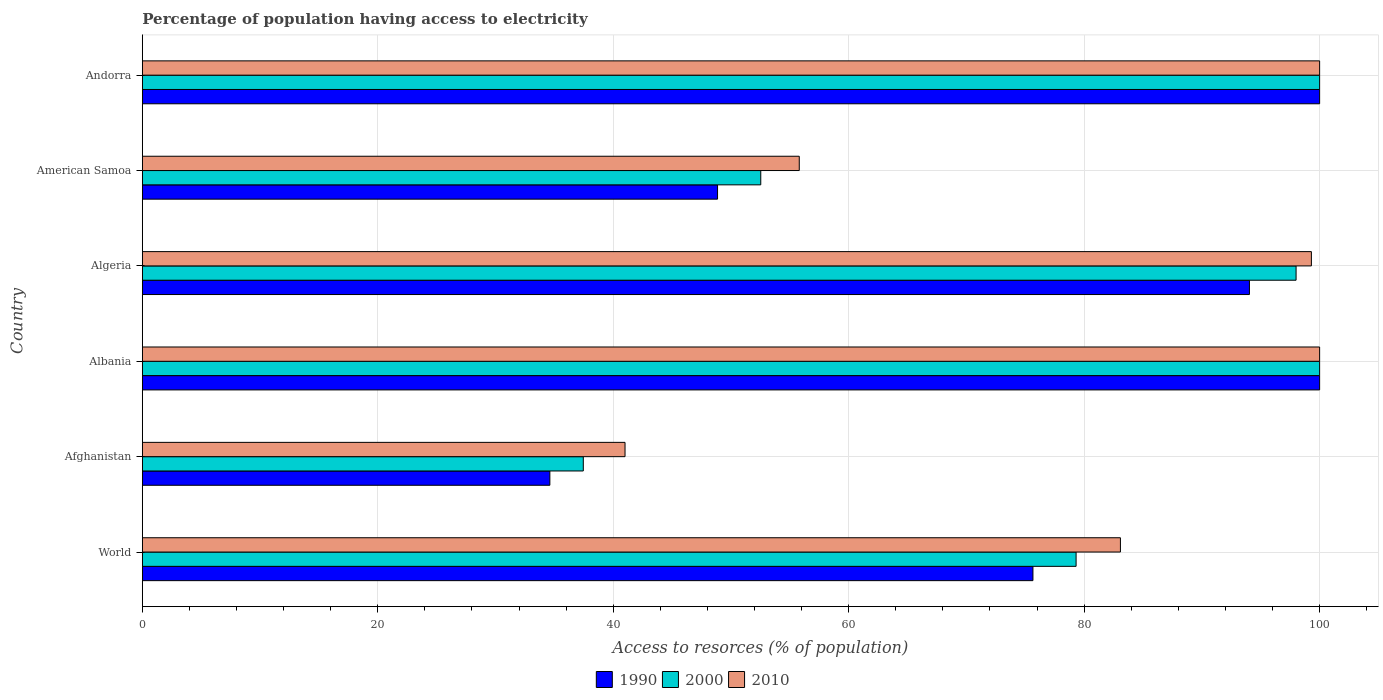Are the number of bars per tick equal to the number of legend labels?
Your answer should be compact. Yes. Are the number of bars on each tick of the Y-axis equal?
Your response must be concise. Yes. What is the percentage of population having access to electricity in 2000 in Albania?
Your answer should be compact. 100. Across all countries, what is the minimum percentage of population having access to electricity in 2010?
Your answer should be very brief. 41. In which country was the percentage of population having access to electricity in 1990 maximum?
Your answer should be very brief. Albania. In which country was the percentage of population having access to electricity in 2010 minimum?
Provide a succinct answer. Afghanistan. What is the total percentage of population having access to electricity in 2000 in the graph?
Your response must be concise. 467.3. What is the difference between the percentage of population having access to electricity in 2010 in Andorra and that in World?
Keep it short and to the point. 16.92. What is the difference between the percentage of population having access to electricity in 2010 in Albania and the percentage of population having access to electricity in 1990 in World?
Your answer should be very brief. 24.35. What is the average percentage of population having access to electricity in 2000 per country?
Your response must be concise. 77.88. What is the difference between the percentage of population having access to electricity in 2000 and percentage of population having access to electricity in 2010 in Algeria?
Ensure brevity in your answer.  -1.3. What is the ratio of the percentage of population having access to electricity in 1990 in Afghanistan to that in World?
Your answer should be compact. 0.46. Is the percentage of population having access to electricity in 2000 in Albania less than that in American Samoa?
Provide a short and direct response. No. What is the difference between the highest and the second highest percentage of population having access to electricity in 1990?
Offer a very short reply. 0. What is the difference between the highest and the lowest percentage of population having access to electricity in 2010?
Give a very brief answer. 59. In how many countries, is the percentage of population having access to electricity in 1990 greater than the average percentage of population having access to electricity in 1990 taken over all countries?
Keep it short and to the point. 4. What does the 1st bar from the top in Andorra represents?
Give a very brief answer. 2010. What does the 1st bar from the bottom in American Samoa represents?
Your response must be concise. 1990. Are all the bars in the graph horizontal?
Ensure brevity in your answer.  Yes. What is the difference between two consecutive major ticks on the X-axis?
Your answer should be compact. 20. Does the graph contain any zero values?
Keep it short and to the point. No. Where does the legend appear in the graph?
Offer a very short reply. Bottom center. What is the title of the graph?
Give a very brief answer. Percentage of population having access to electricity. What is the label or title of the X-axis?
Provide a short and direct response. Access to resorces (% of population). What is the Access to resorces (% of population) of 1990 in World?
Give a very brief answer. 75.65. What is the Access to resorces (% of population) in 2000 in World?
Provide a succinct answer. 79.31. What is the Access to resorces (% of population) of 2010 in World?
Keep it short and to the point. 83.08. What is the Access to resorces (% of population) of 1990 in Afghanistan?
Your answer should be compact. 34.62. What is the Access to resorces (% of population) of 2000 in Afghanistan?
Your answer should be compact. 37.46. What is the Access to resorces (% of population) of 1990 in Albania?
Ensure brevity in your answer.  100. What is the Access to resorces (% of population) of 2000 in Albania?
Your answer should be very brief. 100. What is the Access to resorces (% of population) in 1990 in Algeria?
Offer a very short reply. 94.04. What is the Access to resorces (% of population) in 2010 in Algeria?
Your answer should be very brief. 99.3. What is the Access to resorces (% of population) in 1990 in American Samoa?
Provide a short and direct response. 48.86. What is the Access to resorces (% of population) in 2000 in American Samoa?
Give a very brief answer. 52.53. What is the Access to resorces (% of population) of 2010 in American Samoa?
Offer a very short reply. 55.8. What is the Access to resorces (% of population) of 1990 in Andorra?
Provide a short and direct response. 100. Across all countries, what is the maximum Access to resorces (% of population) of 2010?
Give a very brief answer. 100. Across all countries, what is the minimum Access to resorces (% of population) of 1990?
Provide a succinct answer. 34.62. Across all countries, what is the minimum Access to resorces (% of population) in 2000?
Provide a succinct answer. 37.46. Across all countries, what is the minimum Access to resorces (% of population) in 2010?
Ensure brevity in your answer.  41. What is the total Access to resorces (% of population) in 1990 in the graph?
Offer a terse response. 453.16. What is the total Access to resorces (% of population) of 2000 in the graph?
Offer a terse response. 467.3. What is the total Access to resorces (% of population) in 2010 in the graph?
Ensure brevity in your answer.  479.18. What is the difference between the Access to resorces (% of population) in 1990 in World and that in Afghanistan?
Make the answer very short. 41.03. What is the difference between the Access to resorces (% of population) of 2000 in World and that in Afghanistan?
Offer a very short reply. 41.86. What is the difference between the Access to resorces (% of population) in 2010 in World and that in Afghanistan?
Your response must be concise. 42.08. What is the difference between the Access to resorces (% of population) in 1990 in World and that in Albania?
Offer a very short reply. -24.35. What is the difference between the Access to resorces (% of population) in 2000 in World and that in Albania?
Your response must be concise. -20.69. What is the difference between the Access to resorces (% of population) in 2010 in World and that in Albania?
Your answer should be very brief. -16.92. What is the difference between the Access to resorces (% of population) of 1990 in World and that in Algeria?
Your answer should be very brief. -18.39. What is the difference between the Access to resorces (% of population) of 2000 in World and that in Algeria?
Ensure brevity in your answer.  -18.69. What is the difference between the Access to resorces (% of population) of 2010 in World and that in Algeria?
Provide a succinct answer. -16.22. What is the difference between the Access to resorces (% of population) in 1990 in World and that in American Samoa?
Make the answer very short. 26.79. What is the difference between the Access to resorces (% of population) in 2000 in World and that in American Samoa?
Provide a succinct answer. 26.78. What is the difference between the Access to resorces (% of population) of 2010 in World and that in American Samoa?
Offer a very short reply. 27.28. What is the difference between the Access to resorces (% of population) of 1990 in World and that in Andorra?
Make the answer very short. -24.35. What is the difference between the Access to resorces (% of population) of 2000 in World and that in Andorra?
Make the answer very short. -20.69. What is the difference between the Access to resorces (% of population) in 2010 in World and that in Andorra?
Make the answer very short. -16.92. What is the difference between the Access to resorces (% of population) of 1990 in Afghanistan and that in Albania?
Your response must be concise. -65.38. What is the difference between the Access to resorces (% of population) of 2000 in Afghanistan and that in Albania?
Your answer should be compact. -62.54. What is the difference between the Access to resorces (% of population) of 2010 in Afghanistan and that in Albania?
Ensure brevity in your answer.  -59. What is the difference between the Access to resorces (% of population) of 1990 in Afghanistan and that in Algeria?
Offer a very short reply. -59.42. What is the difference between the Access to resorces (% of population) in 2000 in Afghanistan and that in Algeria?
Keep it short and to the point. -60.54. What is the difference between the Access to resorces (% of population) in 2010 in Afghanistan and that in Algeria?
Give a very brief answer. -58.3. What is the difference between the Access to resorces (% of population) in 1990 in Afghanistan and that in American Samoa?
Ensure brevity in your answer.  -14.24. What is the difference between the Access to resorces (% of population) in 2000 in Afghanistan and that in American Samoa?
Ensure brevity in your answer.  -15.07. What is the difference between the Access to resorces (% of population) in 2010 in Afghanistan and that in American Samoa?
Your answer should be very brief. -14.8. What is the difference between the Access to resorces (% of population) in 1990 in Afghanistan and that in Andorra?
Provide a succinct answer. -65.38. What is the difference between the Access to resorces (% of population) of 2000 in Afghanistan and that in Andorra?
Give a very brief answer. -62.54. What is the difference between the Access to resorces (% of population) in 2010 in Afghanistan and that in Andorra?
Your answer should be compact. -59. What is the difference between the Access to resorces (% of population) of 1990 in Albania and that in Algeria?
Your answer should be compact. 5.96. What is the difference between the Access to resorces (% of population) in 2000 in Albania and that in Algeria?
Ensure brevity in your answer.  2. What is the difference between the Access to resorces (% of population) of 2010 in Albania and that in Algeria?
Provide a short and direct response. 0.7. What is the difference between the Access to resorces (% of population) of 1990 in Albania and that in American Samoa?
Your response must be concise. 51.14. What is the difference between the Access to resorces (% of population) in 2000 in Albania and that in American Samoa?
Provide a succinct answer. 47.47. What is the difference between the Access to resorces (% of population) in 2010 in Albania and that in American Samoa?
Your answer should be compact. 44.2. What is the difference between the Access to resorces (% of population) in 1990 in Albania and that in Andorra?
Make the answer very short. 0. What is the difference between the Access to resorces (% of population) of 2000 in Albania and that in Andorra?
Your answer should be compact. 0. What is the difference between the Access to resorces (% of population) of 1990 in Algeria and that in American Samoa?
Offer a very short reply. 45.18. What is the difference between the Access to resorces (% of population) in 2000 in Algeria and that in American Samoa?
Offer a very short reply. 45.47. What is the difference between the Access to resorces (% of population) in 2010 in Algeria and that in American Samoa?
Provide a succinct answer. 43.5. What is the difference between the Access to resorces (% of population) of 1990 in Algeria and that in Andorra?
Ensure brevity in your answer.  -5.96. What is the difference between the Access to resorces (% of population) of 2000 in Algeria and that in Andorra?
Provide a short and direct response. -2. What is the difference between the Access to resorces (% of population) in 2010 in Algeria and that in Andorra?
Give a very brief answer. -0.7. What is the difference between the Access to resorces (% of population) in 1990 in American Samoa and that in Andorra?
Keep it short and to the point. -51.14. What is the difference between the Access to resorces (% of population) in 2000 in American Samoa and that in Andorra?
Give a very brief answer. -47.47. What is the difference between the Access to resorces (% of population) in 2010 in American Samoa and that in Andorra?
Provide a succinct answer. -44.2. What is the difference between the Access to resorces (% of population) in 1990 in World and the Access to resorces (% of population) in 2000 in Afghanistan?
Provide a succinct answer. 38.19. What is the difference between the Access to resorces (% of population) of 1990 in World and the Access to resorces (% of population) of 2010 in Afghanistan?
Give a very brief answer. 34.65. What is the difference between the Access to resorces (% of population) of 2000 in World and the Access to resorces (% of population) of 2010 in Afghanistan?
Offer a terse response. 38.31. What is the difference between the Access to resorces (% of population) in 1990 in World and the Access to resorces (% of population) in 2000 in Albania?
Give a very brief answer. -24.35. What is the difference between the Access to resorces (% of population) in 1990 in World and the Access to resorces (% of population) in 2010 in Albania?
Provide a short and direct response. -24.35. What is the difference between the Access to resorces (% of population) in 2000 in World and the Access to resorces (% of population) in 2010 in Albania?
Your answer should be compact. -20.69. What is the difference between the Access to resorces (% of population) of 1990 in World and the Access to resorces (% of population) of 2000 in Algeria?
Your response must be concise. -22.35. What is the difference between the Access to resorces (% of population) of 1990 in World and the Access to resorces (% of population) of 2010 in Algeria?
Keep it short and to the point. -23.65. What is the difference between the Access to resorces (% of population) in 2000 in World and the Access to resorces (% of population) in 2010 in Algeria?
Provide a short and direct response. -19.99. What is the difference between the Access to resorces (% of population) of 1990 in World and the Access to resorces (% of population) of 2000 in American Samoa?
Ensure brevity in your answer.  23.12. What is the difference between the Access to resorces (% of population) of 1990 in World and the Access to resorces (% of population) of 2010 in American Samoa?
Your answer should be compact. 19.85. What is the difference between the Access to resorces (% of population) in 2000 in World and the Access to resorces (% of population) in 2010 in American Samoa?
Keep it short and to the point. 23.51. What is the difference between the Access to resorces (% of population) of 1990 in World and the Access to resorces (% of population) of 2000 in Andorra?
Your answer should be compact. -24.35. What is the difference between the Access to resorces (% of population) of 1990 in World and the Access to resorces (% of population) of 2010 in Andorra?
Make the answer very short. -24.35. What is the difference between the Access to resorces (% of population) in 2000 in World and the Access to resorces (% of population) in 2010 in Andorra?
Your answer should be compact. -20.69. What is the difference between the Access to resorces (% of population) of 1990 in Afghanistan and the Access to resorces (% of population) of 2000 in Albania?
Make the answer very short. -65.38. What is the difference between the Access to resorces (% of population) in 1990 in Afghanistan and the Access to resorces (% of population) in 2010 in Albania?
Your answer should be compact. -65.38. What is the difference between the Access to resorces (% of population) in 2000 in Afghanistan and the Access to resorces (% of population) in 2010 in Albania?
Keep it short and to the point. -62.54. What is the difference between the Access to resorces (% of population) of 1990 in Afghanistan and the Access to resorces (% of population) of 2000 in Algeria?
Ensure brevity in your answer.  -63.38. What is the difference between the Access to resorces (% of population) in 1990 in Afghanistan and the Access to resorces (% of population) in 2010 in Algeria?
Offer a terse response. -64.68. What is the difference between the Access to resorces (% of population) of 2000 in Afghanistan and the Access to resorces (% of population) of 2010 in Algeria?
Ensure brevity in your answer.  -61.84. What is the difference between the Access to resorces (% of population) in 1990 in Afghanistan and the Access to resorces (% of population) in 2000 in American Samoa?
Offer a very short reply. -17.91. What is the difference between the Access to resorces (% of population) of 1990 in Afghanistan and the Access to resorces (% of population) of 2010 in American Samoa?
Ensure brevity in your answer.  -21.18. What is the difference between the Access to resorces (% of population) of 2000 in Afghanistan and the Access to resorces (% of population) of 2010 in American Samoa?
Give a very brief answer. -18.34. What is the difference between the Access to resorces (% of population) of 1990 in Afghanistan and the Access to resorces (% of population) of 2000 in Andorra?
Your answer should be very brief. -65.38. What is the difference between the Access to resorces (% of population) of 1990 in Afghanistan and the Access to resorces (% of population) of 2010 in Andorra?
Provide a succinct answer. -65.38. What is the difference between the Access to resorces (% of population) of 2000 in Afghanistan and the Access to resorces (% of population) of 2010 in Andorra?
Your response must be concise. -62.54. What is the difference between the Access to resorces (% of population) of 1990 in Albania and the Access to resorces (% of population) of 2010 in Algeria?
Give a very brief answer. 0.7. What is the difference between the Access to resorces (% of population) of 1990 in Albania and the Access to resorces (% of population) of 2000 in American Samoa?
Give a very brief answer. 47.47. What is the difference between the Access to resorces (% of population) in 1990 in Albania and the Access to resorces (% of population) in 2010 in American Samoa?
Your response must be concise. 44.2. What is the difference between the Access to resorces (% of population) in 2000 in Albania and the Access to resorces (% of population) in 2010 in American Samoa?
Provide a short and direct response. 44.2. What is the difference between the Access to resorces (% of population) of 1990 in Albania and the Access to resorces (% of population) of 2000 in Andorra?
Ensure brevity in your answer.  0. What is the difference between the Access to resorces (% of population) in 2000 in Albania and the Access to resorces (% of population) in 2010 in Andorra?
Ensure brevity in your answer.  0. What is the difference between the Access to resorces (% of population) of 1990 in Algeria and the Access to resorces (% of population) of 2000 in American Samoa?
Offer a terse response. 41.51. What is the difference between the Access to resorces (% of population) in 1990 in Algeria and the Access to resorces (% of population) in 2010 in American Samoa?
Ensure brevity in your answer.  38.24. What is the difference between the Access to resorces (% of population) of 2000 in Algeria and the Access to resorces (% of population) of 2010 in American Samoa?
Provide a succinct answer. 42.2. What is the difference between the Access to resorces (% of population) of 1990 in Algeria and the Access to resorces (% of population) of 2000 in Andorra?
Your answer should be very brief. -5.96. What is the difference between the Access to resorces (% of population) of 1990 in Algeria and the Access to resorces (% of population) of 2010 in Andorra?
Provide a succinct answer. -5.96. What is the difference between the Access to resorces (% of population) of 2000 in Algeria and the Access to resorces (% of population) of 2010 in Andorra?
Ensure brevity in your answer.  -2. What is the difference between the Access to resorces (% of population) in 1990 in American Samoa and the Access to resorces (% of population) in 2000 in Andorra?
Give a very brief answer. -51.14. What is the difference between the Access to resorces (% of population) of 1990 in American Samoa and the Access to resorces (% of population) of 2010 in Andorra?
Provide a succinct answer. -51.14. What is the difference between the Access to resorces (% of population) of 2000 in American Samoa and the Access to resorces (% of population) of 2010 in Andorra?
Your response must be concise. -47.47. What is the average Access to resorces (% of population) of 1990 per country?
Your answer should be very brief. 75.53. What is the average Access to resorces (% of population) of 2000 per country?
Provide a short and direct response. 77.88. What is the average Access to resorces (% of population) of 2010 per country?
Ensure brevity in your answer.  79.86. What is the difference between the Access to resorces (% of population) of 1990 and Access to resorces (% of population) of 2000 in World?
Ensure brevity in your answer.  -3.67. What is the difference between the Access to resorces (% of population) of 1990 and Access to resorces (% of population) of 2010 in World?
Keep it short and to the point. -7.43. What is the difference between the Access to resorces (% of population) of 2000 and Access to resorces (% of population) of 2010 in World?
Offer a very short reply. -3.77. What is the difference between the Access to resorces (% of population) of 1990 and Access to resorces (% of population) of 2000 in Afghanistan?
Offer a very short reply. -2.84. What is the difference between the Access to resorces (% of population) of 1990 and Access to resorces (% of population) of 2010 in Afghanistan?
Offer a terse response. -6.38. What is the difference between the Access to resorces (% of population) in 2000 and Access to resorces (% of population) in 2010 in Afghanistan?
Your answer should be compact. -3.54. What is the difference between the Access to resorces (% of population) of 1990 and Access to resorces (% of population) of 2000 in Algeria?
Keep it short and to the point. -3.96. What is the difference between the Access to resorces (% of population) of 1990 and Access to resorces (% of population) of 2010 in Algeria?
Offer a terse response. -5.26. What is the difference between the Access to resorces (% of population) in 1990 and Access to resorces (% of population) in 2000 in American Samoa?
Offer a very short reply. -3.67. What is the difference between the Access to resorces (% of population) in 1990 and Access to resorces (% of population) in 2010 in American Samoa?
Provide a short and direct response. -6.94. What is the difference between the Access to resorces (% of population) of 2000 and Access to resorces (% of population) of 2010 in American Samoa?
Offer a terse response. -3.27. What is the difference between the Access to resorces (% of population) in 1990 and Access to resorces (% of population) in 2000 in Andorra?
Keep it short and to the point. 0. What is the difference between the Access to resorces (% of population) of 2000 and Access to resorces (% of population) of 2010 in Andorra?
Your response must be concise. 0. What is the ratio of the Access to resorces (% of population) in 1990 in World to that in Afghanistan?
Offer a terse response. 2.19. What is the ratio of the Access to resorces (% of population) in 2000 in World to that in Afghanistan?
Offer a terse response. 2.12. What is the ratio of the Access to resorces (% of population) in 2010 in World to that in Afghanistan?
Offer a very short reply. 2.03. What is the ratio of the Access to resorces (% of population) in 1990 in World to that in Albania?
Give a very brief answer. 0.76. What is the ratio of the Access to resorces (% of population) in 2000 in World to that in Albania?
Your answer should be very brief. 0.79. What is the ratio of the Access to resorces (% of population) of 2010 in World to that in Albania?
Your answer should be compact. 0.83. What is the ratio of the Access to resorces (% of population) of 1990 in World to that in Algeria?
Your response must be concise. 0.8. What is the ratio of the Access to resorces (% of population) in 2000 in World to that in Algeria?
Keep it short and to the point. 0.81. What is the ratio of the Access to resorces (% of population) in 2010 in World to that in Algeria?
Make the answer very short. 0.84. What is the ratio of the Access to resorces (% of population) of 1990 in World to that in American Samoa?
Your response must be concise. 1.55. What is the ratio of the Access to resorces (% of population) of 2000 in World to that in American Samoa?
Keep it short and to the point. 1.51. What is the ratio of the Access to resorces (% of population) of 2010 in World to that in American Samoa?
Offer a terse response. 1.49. What is the ratio of the Access to resorces (% of population) of 1990 in World to that in Andorra?
Offer a very short reply. 0.76. What is the ratio of the Access to resorces (% of population) in 2000 in World to that in Andorra?
Make the answer very short. 0.79. What is the ratio of the Access to resorces (% of population) of 2010 in World to that in Andorra?
Provide a succinct answer. 0.83. What is the ratio of the Access to resorces (% of population) in 1990 in Afghanistan to that in Albania?
Ensure brevity in your answer.  0.35. What is the ratio of the Access to resorces (% of population) in 2000 in Afghanistan to that in Albania?
Your response must be concise. 0.37. What is the ratio of the Access to resorces (% of population) in 2010 in Afghanistan to that in Albania?
Your response must be concise. 0.41. What is the ratio of the Access to resorces (% of population) of 1990 in Afghanistan to that in Algeria?
Your answer should be compact. 0.37. What is the ratio of the Access to resorces (% of population) of 2000 in Afghanistan to that in Algeria?
Provide a short and direct response. 0.38. What is the ratio of the Access to resorces (% of population) in 2010 in Afghanistan to that in Algeria?
Provide a short and direct response. 0.41. What is the ratio of the Access to resorces (% of population) in 1990 in Afghanistan to that in American Samoa?
Ensure brevity in your answer.  0.71. What is the ratio of the Access to resorces (% of population) of 2000 in Afghanistan to that in American Samoa?
Your answer should be very brief. 0.71. What is the ratio of the Access to resorces (% of population) in 2010 in Afghanistan to that in American Samoa?
Offer a very short reply. 0.73. What is the ratio of the Access to resorces (% of population) in 1990 in Afghanistan to that in Andorra?
Provide a short and direct response. 0.35. What is the ratio of the Access to resorces (% of population) in 2000 in Afghanistan to that in Andorra?
Keep it short and to the point. 0.37. What is the ratio of the Access to resorces (% of population) in 2010 in Afghanistan to that in Andorra?
Provide a short and direct response. 0.41. What is the ratio of the Access to resorces (% of population) in 1990 in Albania to that in Algeria?
Offer a very short reply. 1.06. What is the ratio of the Access to resorces (% of population) in 2000 in Albania to that in Algeria?
Keep it short and to the point. 1.02. What is the ratio of the Access to resorces (% of population) of 1990 in Albania to that in American Samoa?
Your response must be concise. 2.05. What is the ratio of the Access to resorces (% of population) of 2000 in Albania to that in American Samoa?
Keep it short and to the point. 1.9. What is the ratio of the Access to resorces (% of population) of 2010 in Albania to that in American Samoa?
Ensure brevity in your answer.  1.79. What is the ratio of the Access to resorces (% of population) in 2000 in Albania to that in Andorra?
Make the answer very short. 1. What is the ratio of the Access to resorces (% of population) in 2010 in Albania to that in Andorra?
Your response must be concise. 1. What is the ratio of the Access to resorces (% of population) of 1990 in Algeria to that in American Samoa?
Keep it short and to the point. 1.92. What is the ratio of the Access to resorces (% of population) of 2000 in Algeria to that in American Samoa?
Your answer should be compact. 1.87. What is the ratio of the Access to resorces (% of population) of 2010 in Algeria to that in American Samoa?
Your answer should be very brief. 1.78. What is the ratio of the Access to resorces (% of population) of 1990 in Algeria to that in Andorra?
Provide a short and direct response. 0.94. What is the ratio of the Access to resorces (% of population) of 2000 in Algeria to that in Andorra?
Make the answer very short. 0.98. What is the ratio of the Access to resorces (% of population) in 1990 in American Samoa to that in Andorra?
Your response must be concise. 0.49. What is the ratio of the Access to resorces (% of population) of 2000 in American Samoa to that in Andorra?
Your response must be concise. 0.53. What is the ratio of the Access to resorces (% of population) of 2010 in American Samoa to that in Andorra?
Your answer should be very brief. 0.56. What is the difference between the highest and the second highest Access to resorces (% of population) in 2000?
Offer a very short reply. 0. What is the difference between the highest and the second highest Access to resorces (% of population) in 2010?
Offer a terse response. 0. What is the difference between the highest and the lowest Access to resorces (% of population) of 1990?
Offer a terse response. 65.38. What is the difference between the highest and the lowest Access to resorces (% of population) of 2000?
Keep it short and to the point. 62.54. 